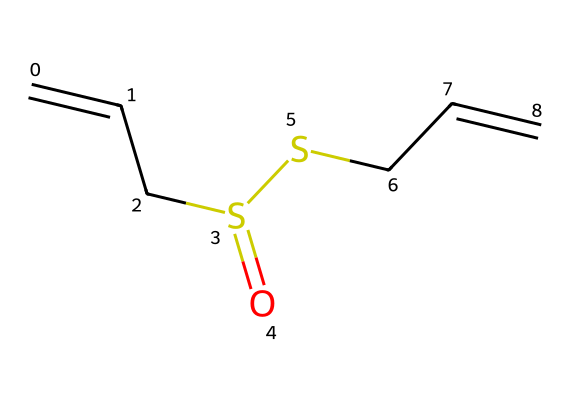How many carbon atoms are in allicin? By examining the SMILES representation, we can count the carbon atoms present in the structure. The SMILES shows several 'C' characters, totaling six carbon atoms.
Answer: six What are the functional groups present in allicin? Looking at the SMILES representation, we note the presence of a sulfoxide (S=O) and a thioether (S-C). Therefore, the functional groups present include sulfoxide and thioether.
Answer: sulfoxide, thioether How many sulfur atoms are there in allicin? In the SMILES, we see two 'S' characters, indicating there are two sulfur atoms within the structure of allicin.
Answer: two Does allicin contain any double bonds? In the SMILES string, the presence of '=' indicates that there are double bonds between the carbon atoms, confirming that allicin contains double bonds.
Answer: yes What is the molecular formula of allicin? By interpreting the SMILES, we count 6 carbon (C), 10 hydrogen (H), and 2 sulfur (S) atoms, leading us to deduce the molecular formula C6H10S2 for allicin.
Answer: C6H10S2 What type of compound is allicin classified as? Allicin possesses a sulfur atom within its structure, along with carbon and hydrogen, which categorizes it as a sulfur compound.
Answer: sulfur compound How many rings are in the structure of allicin? The SMILES representation shows straight-chain connections without any indication of circular structures or rings. Therefore, allicin does not contain any rings.
Answer: zero 